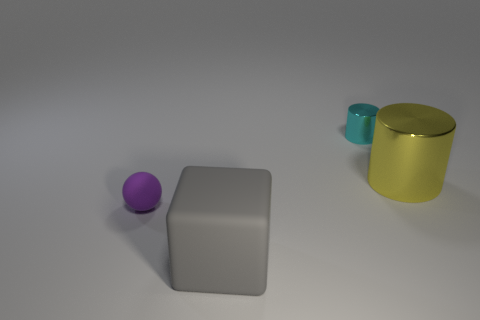The large thing to the left of the cylinder that is in front of the tiny thing that is to the right of the purple ball is made of what material?
Offer a terse response. Rubber. The purple ball that is the same material as the gray block is what size?
Provide a succinct answer. Small. There is a small thing that is right of the rubber thing behind the matte cube; what is its color?
Your answer should be compact. Cyan. How many purple things are the same material as the large gray thing?
Keep it short and to the point. 1. What number of shiny things are either big yellow spheres or purple spheres?
Provide a short and direct response. 0. What material is the cylinder that is the same size as the block?
Make the answer very short. Metal. Is there a tiny cyan cylinder made of the same material as the large gray thing?
Offer a terse response. No. There is a metallic thing in front of the cylinder behind the metal cylinder right of the small shiny thing; what shape is it?
Provide a short and direct response. Cylinder. Do the cyan shiny thing and the rubber object that is in front of the purple thing have the same size?
Make the answer very short. No. There is a thing that is behind the large matte cube and in front of the yellow metal thing; what shape is it?
Keep it short and to the point. Sphere. 